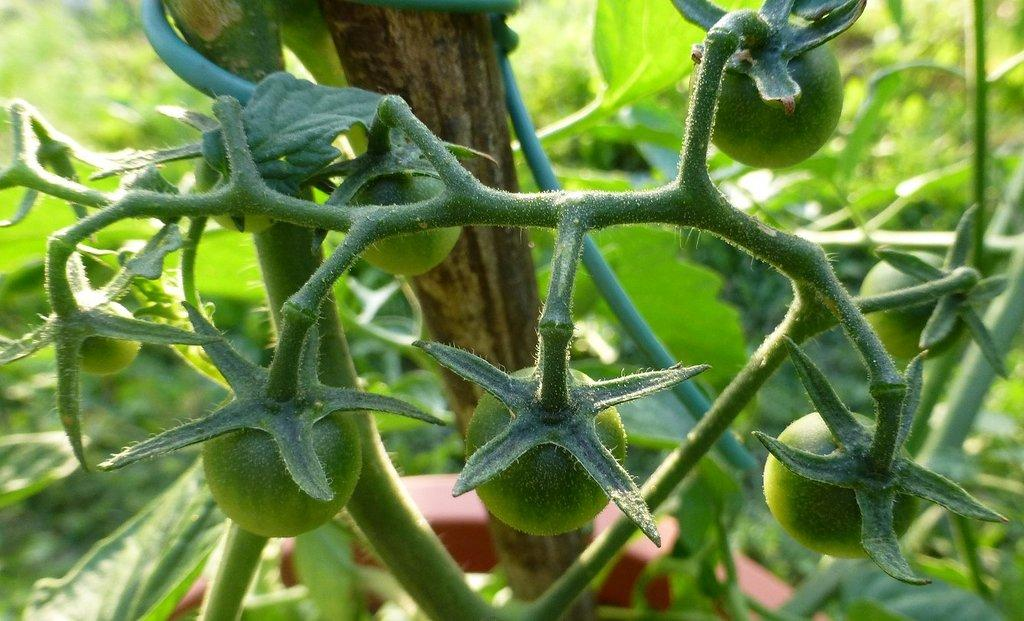What type of fruit can be seen in the image? There are tomatoes in the image. What else is present in the image besides the tomatoes? There are leaves in the image. What is the name of the shop where the tomatoes were purchased in the image? There is no shop present in the image, as it only features tomatoes and leaves. 